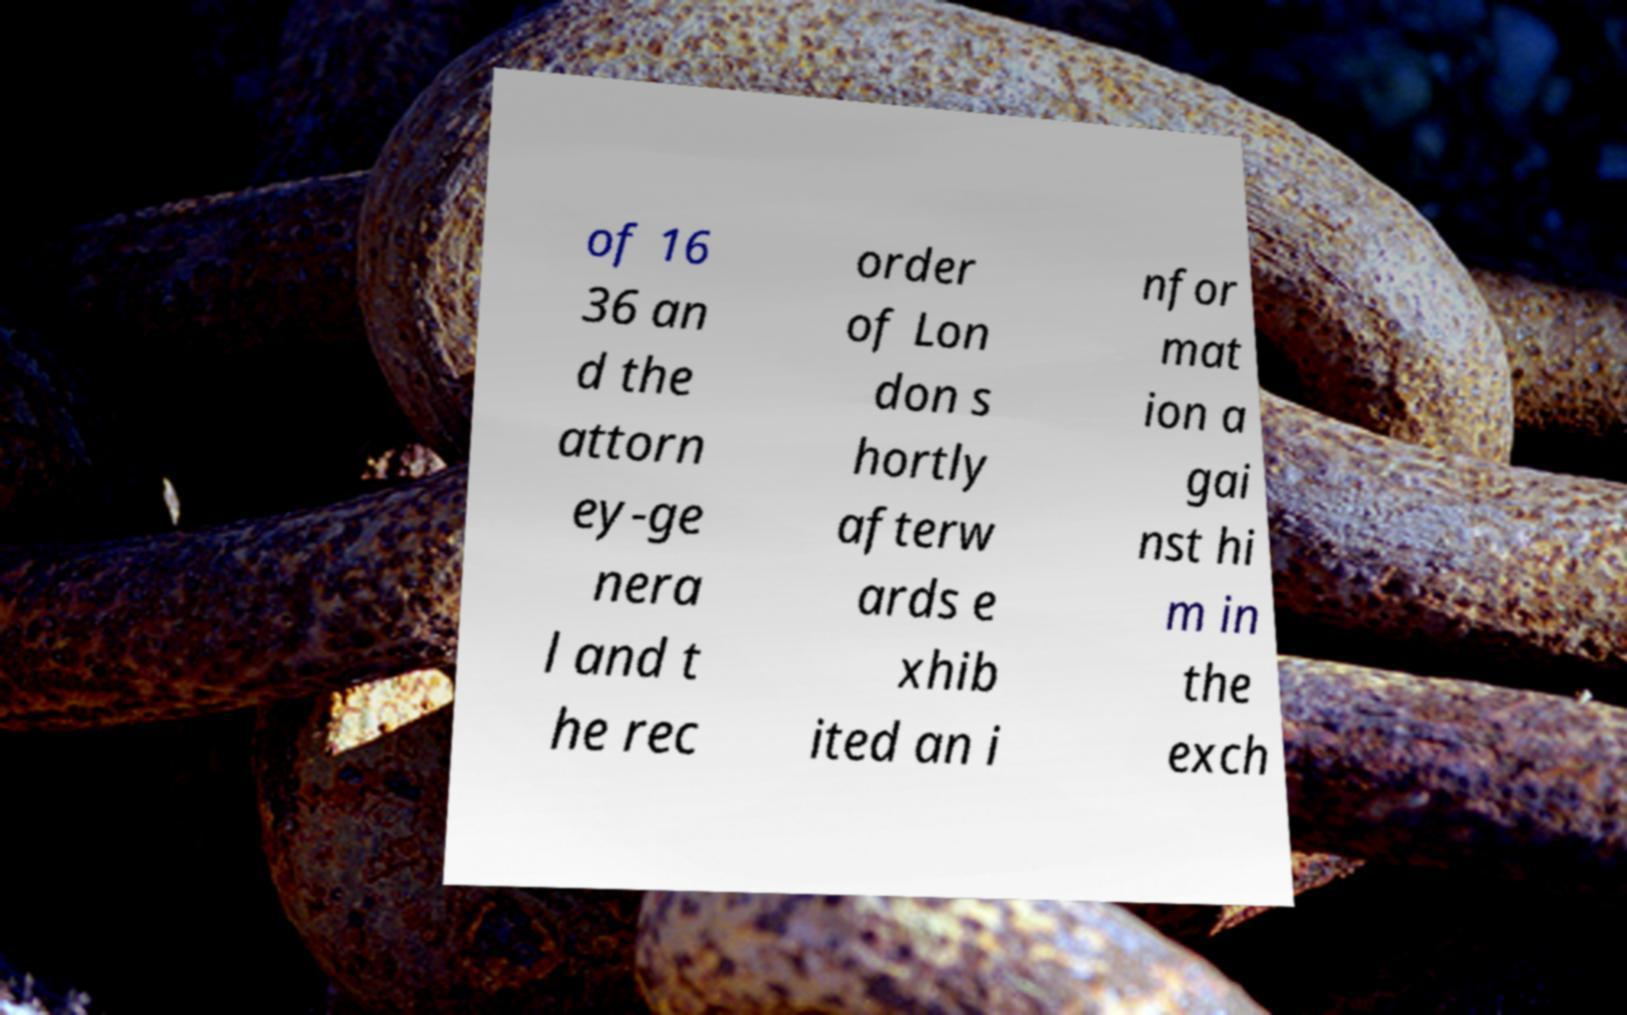Can you read and provide the text displayed in the image?This photo seems to have some interesting text. Can you extract and type it out for me? of 16 36 an d the attorn ey-ge nera l and t he rec order of Lon don s hortly afterw ards e xhib ited an i nfor mat ion a gai nst hi m in the exch 